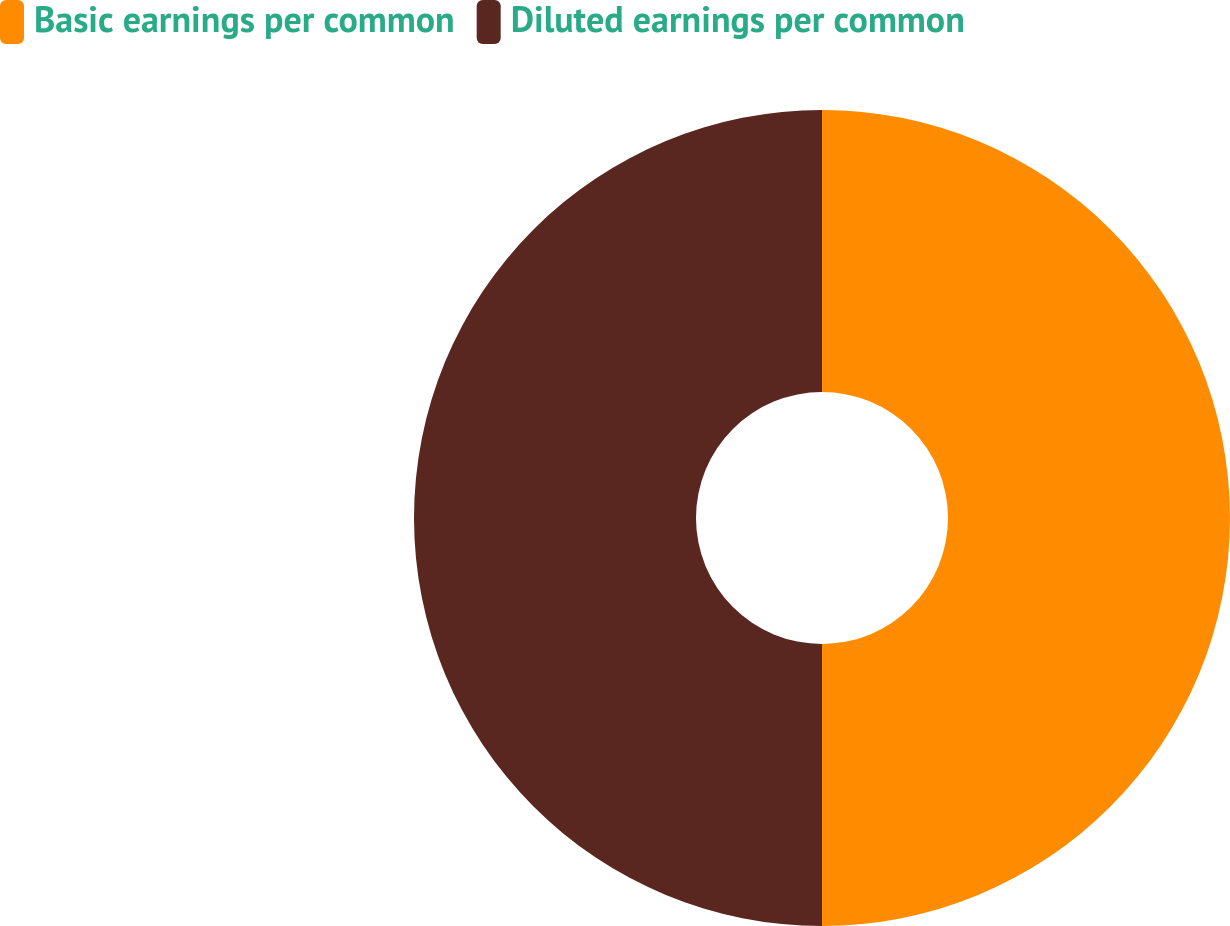Convert chart. <chart><loc_0><loc_0><loc_500><loc_500><pie_chart><fcel>Basic earnings per common<fcel>Diluted earnings per common<nl><fcel>50.0%<fcel>50.0%<nl></chart> 